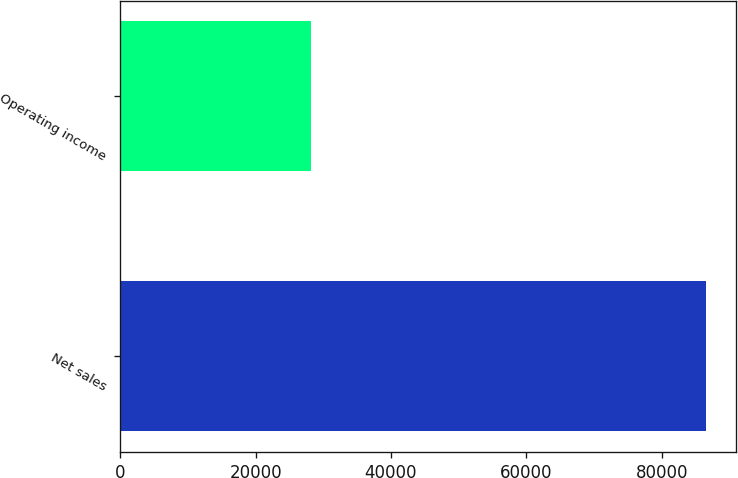Convert chart to OTSL. <chart><loc_0><loc_0><loc_500><loc_500><bar_chart><fcel>Net sales<fcel>Operating income<nl><fcel>86613<fcel>28172<nl></chart> 